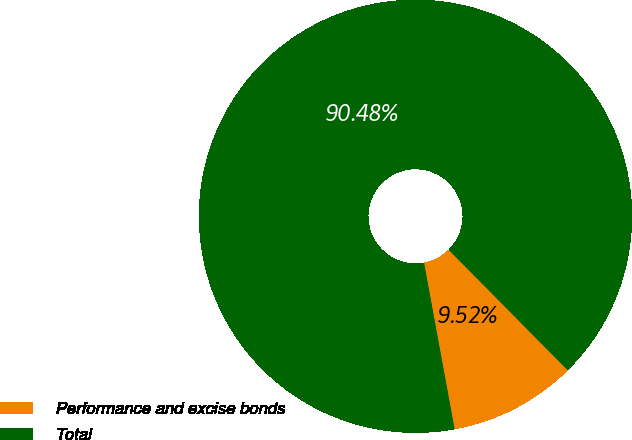Convert chart to OTSL. <chart><loc_0><loc_0><loc_500><loc_500><pie_chart><fcel>Performance and excise bonds<fcel>Total<nl><fcel>9.52%<fcel>90.48%<nl></chart> 